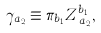<formula> <loc_0><loc_0><loc_500><loc_500>\gamma _ { a _ { 2 } } \equiv \pi _ { b _ { 1 } } Z _ { \, a _ { 2 } } ^ { b _ { 1 } } ,</formula> 